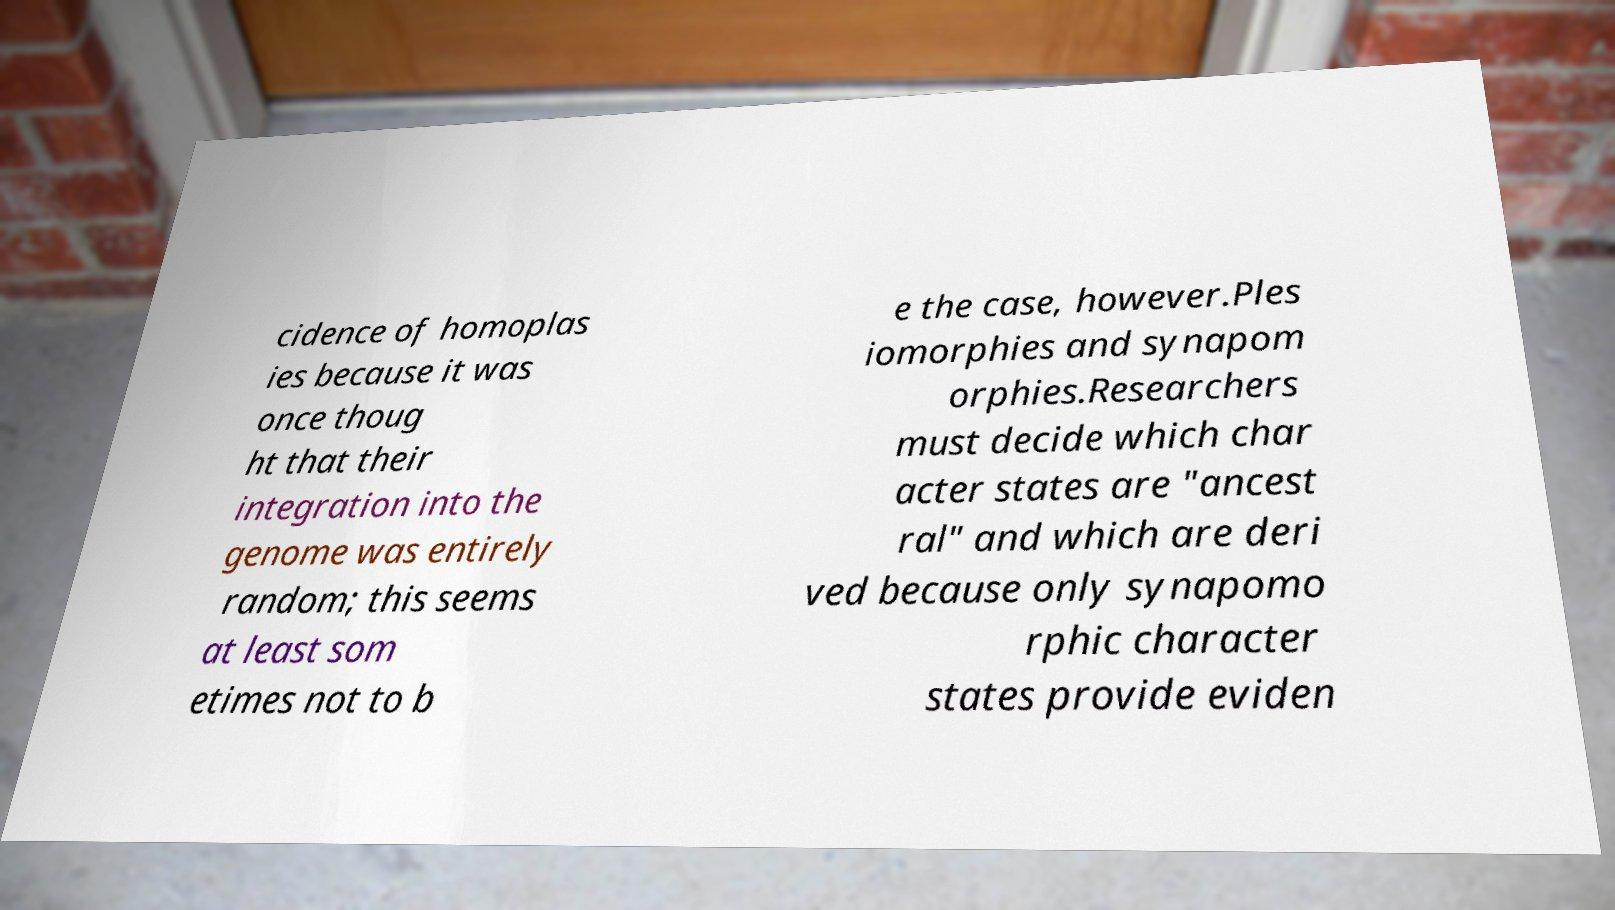What messages or text are displayed in this image? I need them in a readable, typed format. cidence of homoplas ies because it was once thoug ht that their integration into the genome was entirely random; this seems at least som etimes not to b e the case, however.Ples iomorphies and synapom orphies.Researchers must decide which char acter states are "ancest ral" and which are deri ved because only synapomo rphic character states provide eviden 